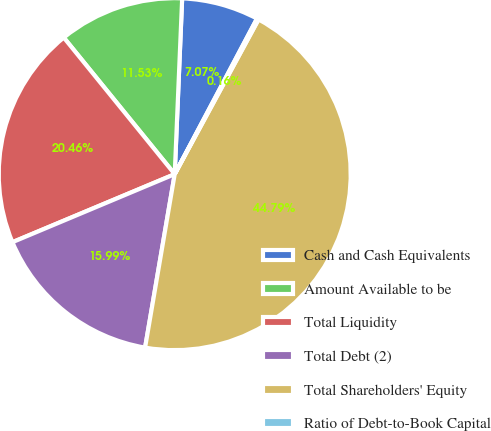<chart> <loc_0><loc_0><loc_500><loc_500><pie_chart><fcel>Cash and Cash Equivalents<fcel>Amount Available to be<fcel>Total Liquidity<fcel>Total Debt (2)<fcel>Total Shareholders' Equity<fcel>Ratio of Debt-to-Book Capital<nl><fcel>7.07%<fcel>11.53%<fcel>20.46%<fcel>15.99%<fcel>44.79%<fcel>0.16%<nl></chart> 